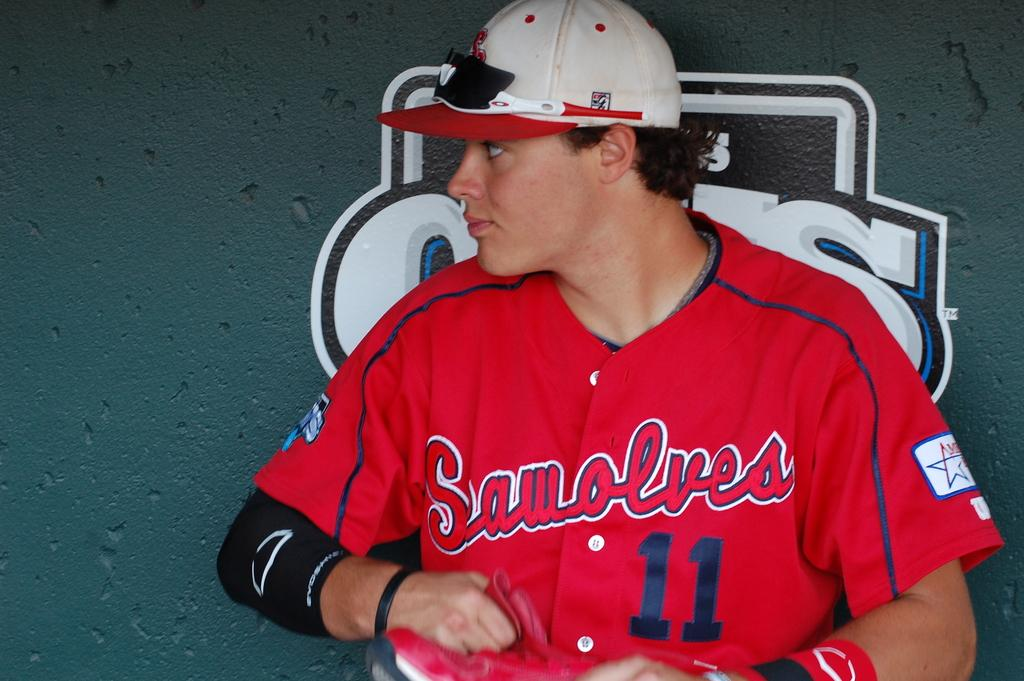What is the main subject of the image? The main subject of the image is a man. Can you describe the man's attire in the image? The man is wearing a cap in the image. What type of education does the man have, as depicted in the image? The image does not provide any information about the man's education. 